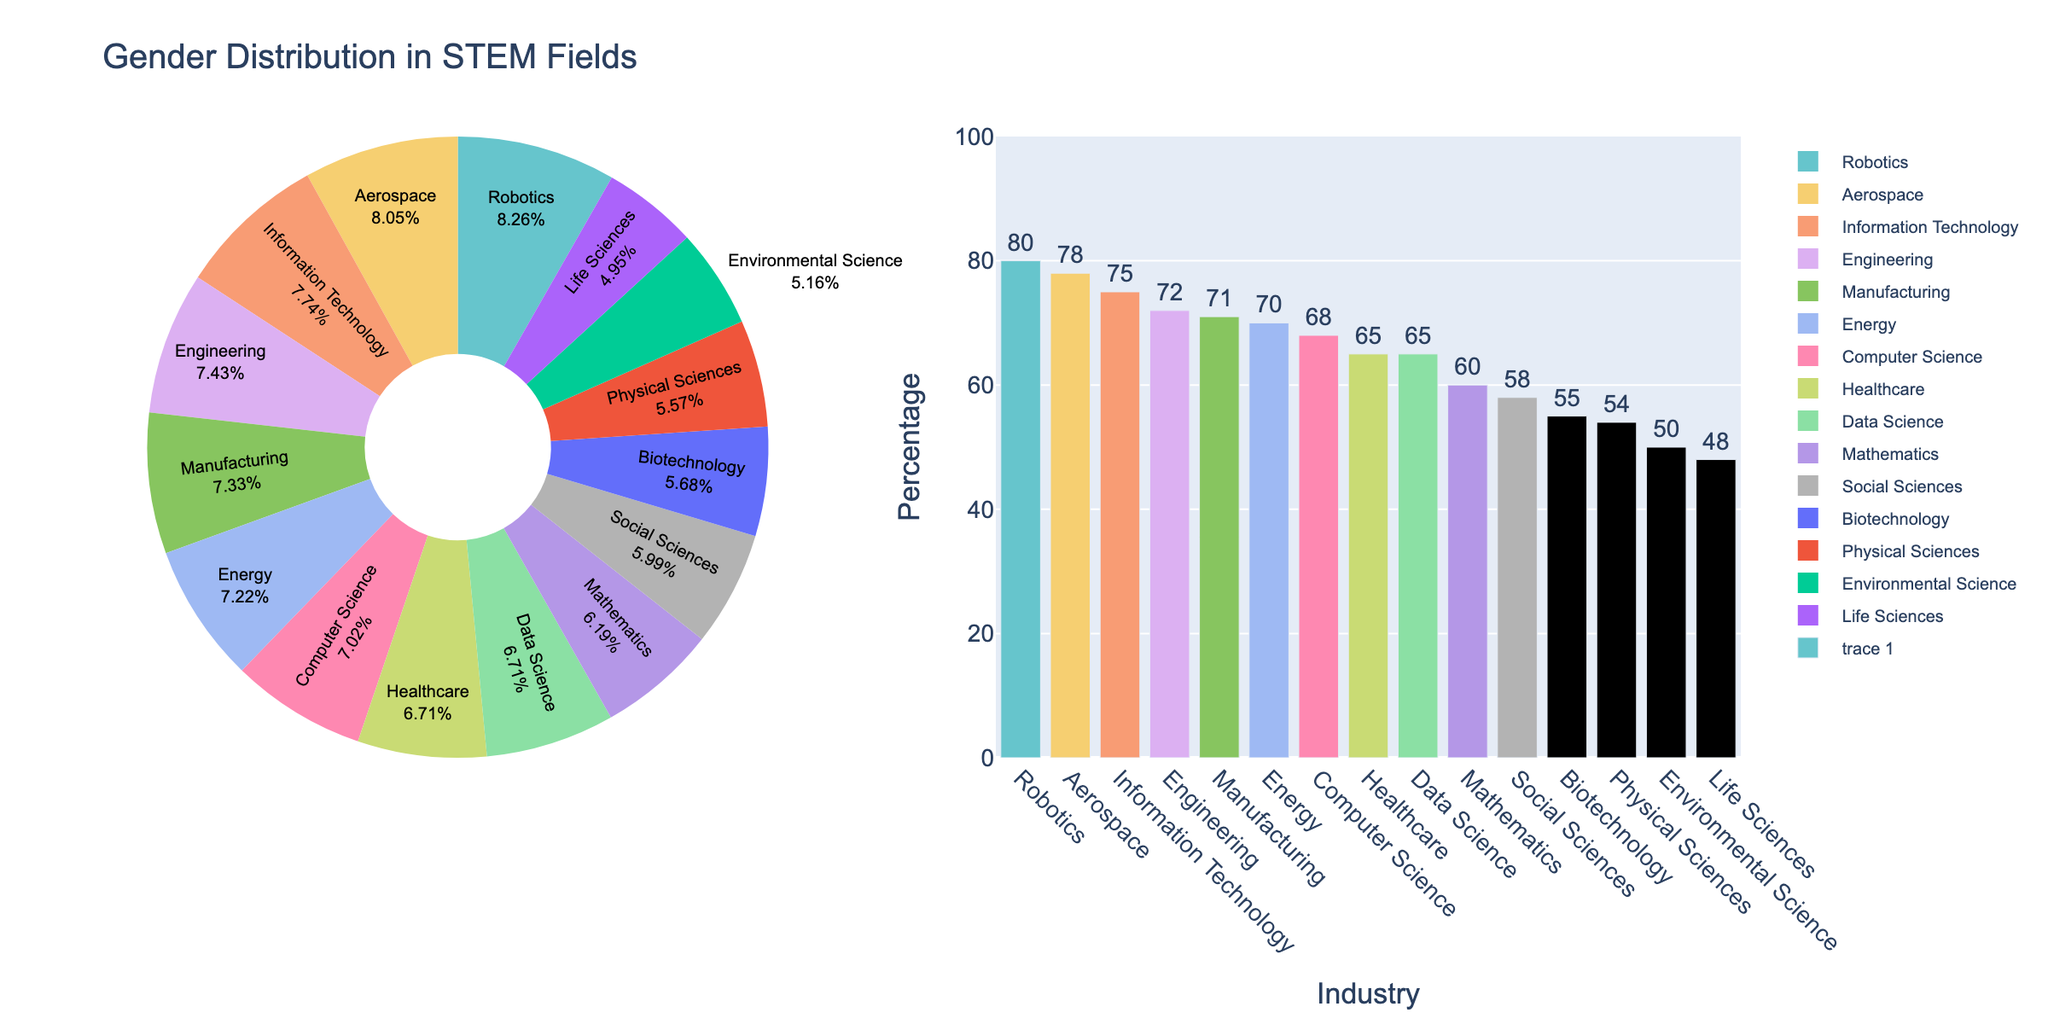How many industries listed have a gender distribution percentage of 65% or higher? To determine the number of industries with a gender distribution percentage of 65% or higher, count the segments where the percentage values are 65 or above. By checking the pie chart, we identify the following industries with 65% or higher: Engineering, Computer Science, Manufacturing, Information Technology, Healthcare, Aerospace, Energy, Robotics, and Data Science. There are 9 such segments.
Answer: 9 Which industry has the highest percentage of gender distribution? The industry with the highest percentage will be represented by the largest segment in the pie chart. Observing the pie chart, we find that Robotics has the highest percentage at 80%.
Answer: Robotics What is the difference in gender distribution percentage between the highest and lowest industries? To calculate this, subtract the percentage of the industry with the lowest distribution from the highest. The highest is Robotics at 80%, and the lowest is Life Sciences at 48%. 80% - 48% = 32%.
Answer: 32% Compare the gender distribution percentages between Aerospace and Life Sciences; which one is higher and by how much? Aerospace has a percentage of 78%, and Life Sciences have 48%. Subtract the lower percentage from the higher one: 78% - 48% = 30%. Aerospace is higher by 30%.
Answer: Aerospace is higher by 30% Which industry has a percentage closest to the average percentage of all industries combined? First, calculate the average percentage of all industries combined. Add all percentages: (72 + 68 + 60 + 54 + 48 + 58 + 71 + 75 + 65 + 78 + 70 + 55 + 50 + 80 + 65) = 969. Divide by the number of industries, which is 15. The average is 969 / 15 = 64.6%. Healthcare and Data Science both have a percentage of 65%, which are closest to the average.
Answer: Healthcare and Data Science Which three industries have the most similar gender distribution percentages? Visually compare the bar heights or percentage values in the pie chart. By observing, we see that Computer Science (68%), Aerospace (78%), and Energy (70%) are close, but better matched visually are Computer Science (68%), Data Science (65%), and Healthcare (65%).
Answer: Computer Science, Data Science, Healthcare If we sum up the percentages of the three industries with the highest gender distribution, what is the total? Identify the three highest percentages, which are Robotics (80%), Aerospace (78%), and Information Technology (75%). Sum them up: 80% + 78% + 75% = 233%.
Answer: 233% What percentage more does Manufacturing have over Environmental Science? Manufacturing has 71%, and Environmental Science has 50%. Subtract the lesser percentage from the higher percentage: 71% - 50% = 21%.
Answer: 21% Among the Life Sciences, Social Sciences, and Biotechnology, which field has the highest percentage, and what is it? Compare Life Sciences (48%), Social Sciences (58%), and Biotechnology (55%). Social Sciences have the highest percentage of 58%.
Answer: Social Sciences, 58% What is the visual difference in the color representation between Engineering and Life Sciences in the pie chart? Look at the specific segments of Engineering and Life Sciences. Engineering might be represented with a certain color (e.g., pastel blue), while Life Sciences might have another (e.g., pastel green). These colors help differentiate the segments visually.
Answer: Different colors representing Engineering and Life Sciences (e.g., pastel blue for Engineering and pastel green for Life Sciences) 